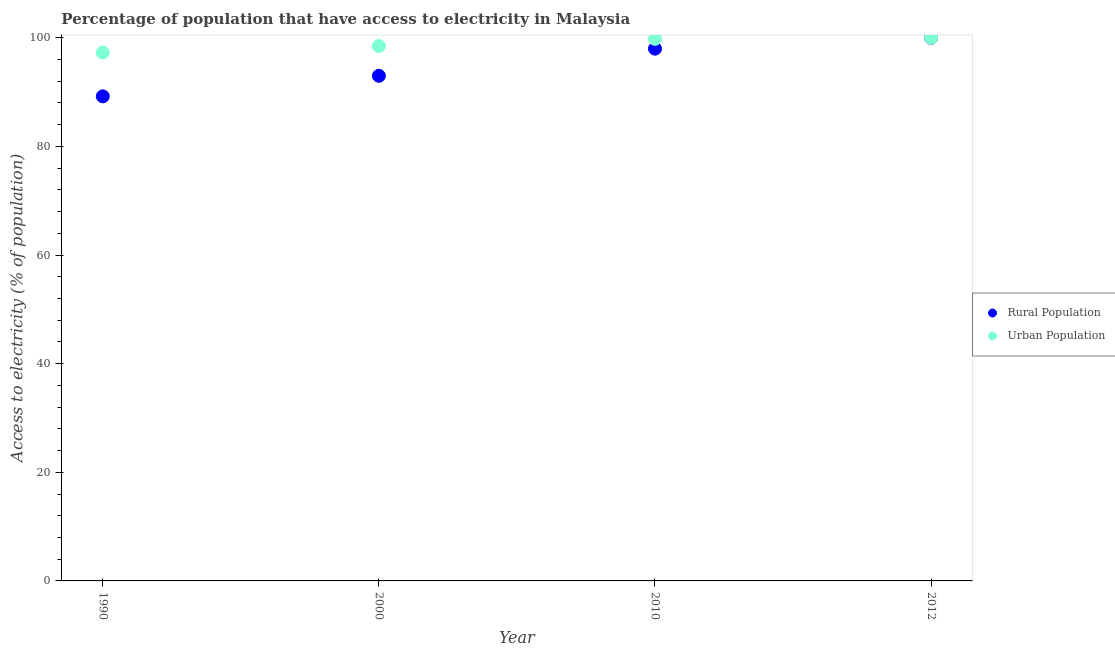What is the percentage of rural population having access to electricity in 2012?
Your answer should be compact. 100. Across all years, what is the maximum percentage of rural population having access to electricity?
Your answer should be compact. 100. Across all years, what is the minimum percentage of rural population having access to electricity?
Your answer should be compact. 89.22. What is the total percentage of urban population having access to electricity in the graph?
Keep it short and to the point. 395.58. What is the difference between the percentage of rural population having access to electricity in 1990 and that in 2010?
Offer a very short reply. -8.78. What is the difference between the percentage of rural population having access to electricity in 1990 and the percentage of urban population having access to electricity in 2000?
Make the answer very short. -9.27. What is the average percentage of urban population having access to electricity per year?
Ensure brevity in your answer.  98.9. In the year 2010, what is the difference between the percentage of urban population having access to electricity and percentage of rural population having access to electricity?
Your answer should be compact. 1.81. In how many years, is the percentage of rural population having access to electricity greater than 32 %?
Make the answer very short. 4. What is the ratio of the percentage of rural population having access to electricity in 1990 to that in 2000?
Your answer should be compact. 0.96. What is the difference between the highest and the second highest percentage of urban population having access to electricity?
Give a very brief answer. 0.19. What is the difference between the highest and the lowest percentage of urban population having access to electricity?
Your answer should be very brief. 2.71. In how many years, is the percentage of rural population having access to electricity greater than the average percentage of rural population having access to electricity taken over all years?
Keep it short and to the point. 2. Does the percentage of rural population having access to electricity monotonically increase over the years?
Offer a terse response. Yes. Is the percentage of urban population having access to electricity strictly less than the percentage of rural population having access to electricity over the years?
Give a very brief answer. No. How many dotlines are there?
Offer a terse response. 2. What is the difference between two consecutive major ticks on the Y-axis?
Make the answer very short. 20. Are the values on the major ticks of Y-axis written in scientific E-notation?
Provide a succinct answer. No. How many legend labels are there?
Make the answer very short. 2. How are the legend labels stacked?
Offer a very short reply. Vertical. What is the title of the graph?
Your answer should be compact. Percentage of population that have access to electricity in Malaysia. What is the label or title of the Y-axis?
Your response must be concise. Access to electricity (% of population). What is the Access to electricity (% of population) of Rural Population in 1990?
Provide a succinct answer. 89.22. What is the Access to electricity (% of population) of Urban Population in 1990?
Your response must be concise. 97.29. What is the Access to electricity (% of population) in Rural Population in 2000?
Give a very brief answer. 93. What is the Access to electricity (% of population) in Urban Population in 2000?
Provide a succinct answer. 98.49. What is the Access to electricity (% of population) of Urban Population in 2010?
Ensure brevity in your answer.  99.81. What is the Access to electricity (% of population) of Rural Population in 2012?
Give a very brief answer. 100. Across all years, what is the minimum Access to electricity (% of population) of Rural Population?
Your answer should be compact. 89.22. Across all years, what is the minimum Access to electricity (% of population) of Urban Population?
Offer a very short reply. 97.29. What is the total Access to electricity (% of population) in Rural Population in the graph?
Provide a succinct answer. 380.22. What is the total Access to electricity (% of population) of Urban Population in the graph?
Give a very brief answer. 395.58. What is the difference between the Access to electricity (% of population) in Rural Population in 1990 and that in 2000?
Your response must be concise. -3.78. What is the difference between the Access to electricity (% of population) of Urban Population in 1990 and that in 2000?
Make the answer very short. -1.2. What is the difference between the Access to electricity (% of population) in Rural Population in 1990 and that in 2010?
Provide a short and direct response. -8.78. What is the difference between the Access to electricity (% of population) in Urban Population in 1990 and that in 2010?
Provide a short and direct response. -2.52. What is the difference between the Access to electricity (% of population) in Rural Population in 1990 and that in 2012?
Your answer should be compact. -10.78. What is the difference between the Access to electricity (% of population) in Urban Population in 1990 and that in 2012?
Ensure brevity in your answer.  -2.71. What is the difference between the Access to electricity (% of population) of Urban Population in 2000 and that in 2010?
Provide a succinct answer. -1.32. What is the difference between the Access to electricity (% of population) of Urban Population in 2000 and that in 2012?
Provide a succinct answer. -1.51. What is the difference between the Access to electricity (% of population) of Urban Population in 2010 and that in 2012?
Your answer should be very brief. -0.19. What is the difference between the Access to electricity (% of population) in Rural Population in 1990 and the Access to electricity (% of population) in Urban Population in 2000?
Your response must be concise. -9.27. What is the difference between the Access to electricity (% of population) of Rural Population in 1990 and the Access to electricity (% of population) of Urban Population in 2010?
Your answer should be compact. -10.59. What is the difference between the Access to electricity (% of population) of Rural Population in 1990 and the Access to electricity (% of population) of Urban Population in 2012?
Make the answer very short. -10.78. What is the difference between the Access to electricity (% of population) in Rural Population in 2000 and the Access to electricity (% of population) in Urban Population in 2010?
Your answer should be compact. -6.81. What is the difference between the Access to electricity (% of population) in Rural Population in 2000 and the Access to electricity (% of population) in Urban Population in 2012?
Offer a terse response. -7. What is the difference between the Access to electricity (% of population) of Rural Population in 2010 and the Access to electricity (% of population) of Urban Population in 2012?
Provide a short and direct response. -2. What is the average Access to electricity (% of population) in Rural Population per year?
Give a very brief answer. 95.05. What is the average Access to electricity (% of population) of Urban Population per year?
Provide a short and direct response. 98.9. In the year 1990, what is the difference between the Access to electricity (% of population) of Rural Population and Access to electricity (% of population) of Urban Population?
Provide a short and direct response. -8.07. In the year 2000, what is the difference between the Access to electricity (% of population) of Rural Population and Access to electricity (% of population) of Urban Population?
Give a very brief answer. -5.49. In the year 2010, what is the difference between the Access to electricity (% of population) in Rural Population and Access to electricity (% of population) in Urban Population?
Offer a terse response. -1.81. In the year 2012, what is the difference between the Access to electricity (% of population) in Rural Population and Access to electricity (% of population) in Urban Population?
Make the answer very short. 0. What is the ratio of the Access to electricity (% of population) in Rural Population in 1990 to that in 2000?
Give a very brief answer. 0.96. What is the ratio of the Access to electricity (% of population) of Urban Population in 1990 to that in 2000?
Offer a very short reply. 0.99. What is the ratio of the Access to electricity (% of population) in Rural Population in 1990 to that in 2010?
Your answer should be very brief. 0.91. What is the ratio of the Access to electricity (% of population) of Urban Population in 1990 to that in 2010?
Your answer should be compact. 0.97. What is the ratio of the Access to electricity (% of population) in Rural Population in 1990 to that in 2012?
Your answer should be very brief. 0.89. What is the ratio of the Access to electricity (% of population) of Urban Population in 1990 to that in 2012?
Make the answer very short. 0.97. What is the ratio of the Access to electricity (% of population) of Rural Population in 2000 to that in 2010?
Provide a short and direct response. 0.95. What is the ratio of the Access to electricity (% of population) in Urban Population in 2000 to that in 2010?
Provide a succinct answer. 0.99. What is the ratio of the Access to electricity (% of population) of Rural Population in 2000 to that in 2012?
Offer a terse response. 0.93. What is the ratio of the Access to electricity (% of population) of Urban Population in 2000 to that in 2012?
Your answer should be compact. 0.98. What is the difference between the highest and the second highest Access to electricity (% of population) in Rural Population?
Provide a short and direct response. 2. What is the difference between the highest and the second highest Access to electricity (% of population) in Urban Population?
Offer a terse response. 0.19. What is the difference between the highest and the lowest Access to electricity (% of population) of Rural Population?
Provide a succinct answer. 10.78. What is the difference between the highest and the lowest Access to electricity (% of population) in Urban Population?
Give a very brief answer. 2.71. 